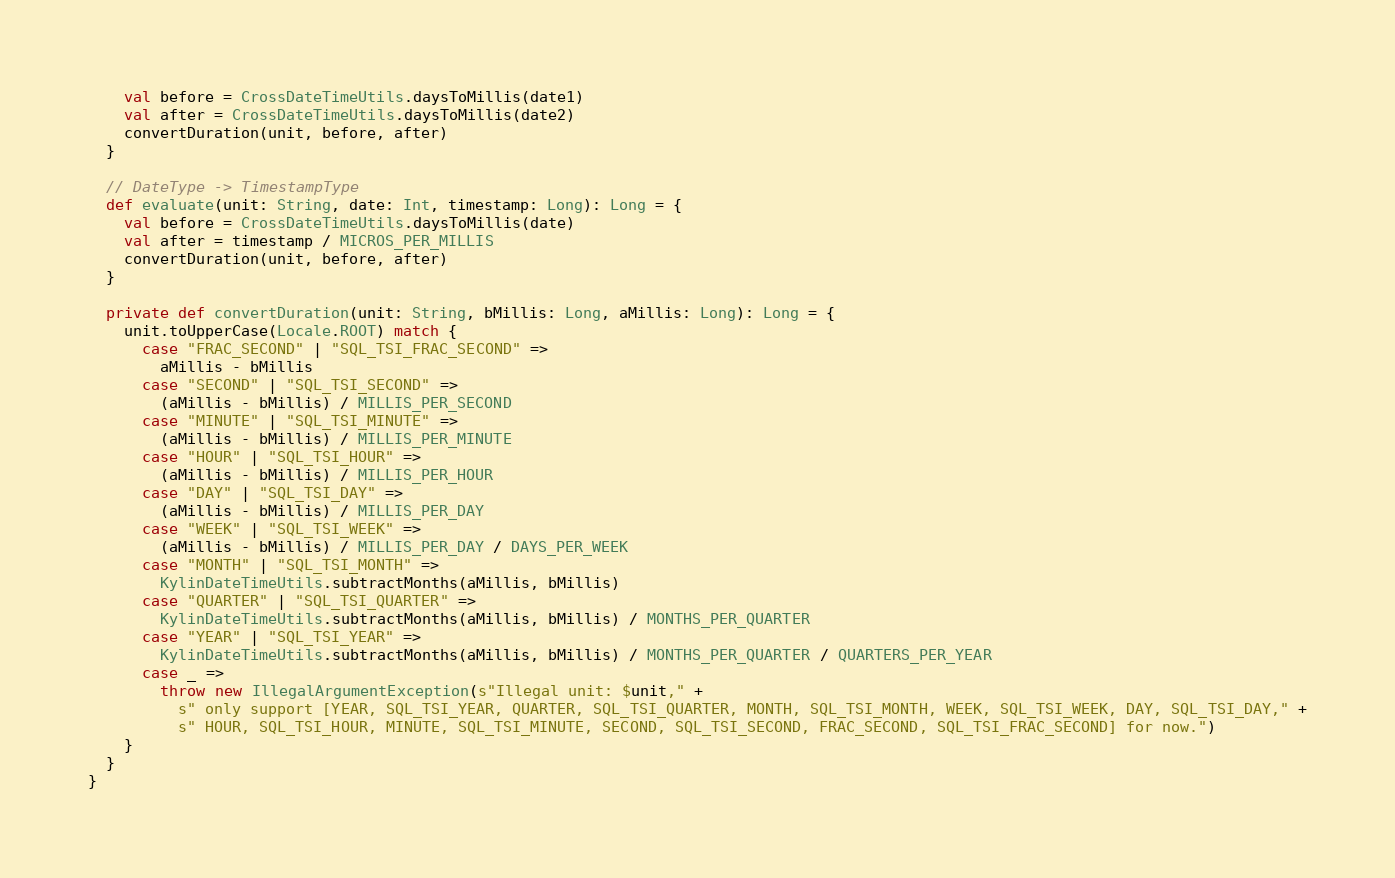<code> <loc_0><loc_0><loc_500><loc_500><_Scala_>    val before = CrossDateTimeUtils.daysToMillis(date1)
    val after = CrossDateTimeUtils.daysToMillis(date2)
    convertDuration(unit, before, after)
  }

  // DateType -> TimestampType
  def evaluate(unit: String, date: Int, timestamp: Long): Long = {
    val before = CrossDateTimeUtils.daysToMillis(date)
    val after = timestamp / MICROS_PER_MILLIS
    convertDuration(unit, before, after)
  }

  private def convertDuration(unit: String, bMillis: Long, aMillis: Long): Long = {
    unit.toUpperCase(Locale.ROOT) match {
      case "FRAC_SECOND" | "SQL_TSI_FRAC_SECOND" =>
        aMillis - bMillis
      case "SECOND" | "SQL_TSI_SECOND" =>
        (aMillis - bMillis) / MILLIS_PER_SECOND
      case "MINUTE" | "SQL_TSI_MINUTE" =>
        (aMillis - bMillis) / MILLIS_PER_MINUTE
      case "HOUR" | "SQL_TSI_HOUR" =>
        (aMillis - bMillis) / MILLIS_PER_HOUR
      case "DAY" | "SQL_TSI_DAY" =>
        (aMillis - bMillis) / MILLIS_PER_DAY
      case "WEEK" | "SQL_TSI_WEEK" =>
        (aMillis - bMillis) / MILLIS_PER_DAY / DAYS_PER_WEEK
      case "MONTH" | "SQL_TSI_MONTH" =>
        KylinDateTimeUtils.subtractMonths(aMillis, bMillis)
      case "QUARTER" | "SQL_TSI_QUARTER" =>
        KylinDateTimeUtils.subtractMonths(aMillis, bMillis) / MONTHS_PER_QUARTER
      case "YEAR" | "SQL_TSI_YEAR" =>
        KylinDateTimeUtils.subtractMonths(aMillis, bMillis) / MONTHS_PER_QUARTER / QUARTERS_PER_YEAR
      case _ =>
        throw new IllegalArgumentException(s"Illegal unit: $unit," +
          s" only support [YEAR, SQL_TSI_YEAR, QUARTER, SQL_TSI_QUARTER, MONTH, SQL_TSI_MONTH, WEEK, SQL_TSI_WEEK, DAY, SQL_TSI_DAY," +
          s" HOUR, SQL_TSI_HOUR, MINUTE, SQL_TSI_MINUTE, SECOND, SQL_TSI_SECOND, FRAC_SECOND, SQL_TSI_FRAC_SECOND] for now.")
    }
  }
}
</code> 